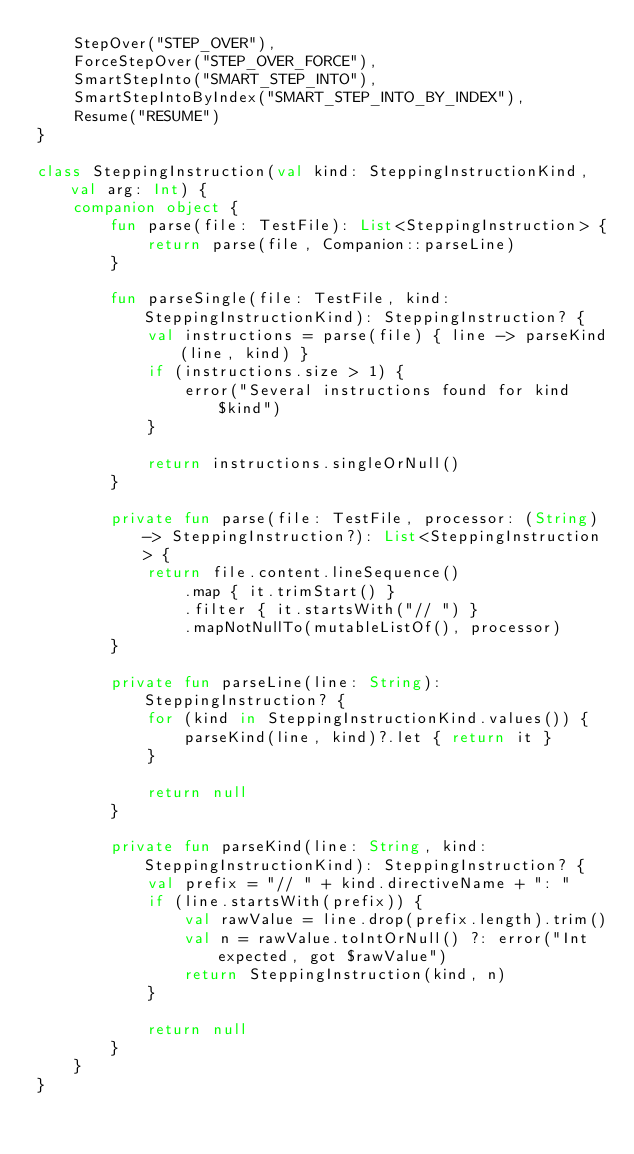<code> <loc_0><loc_0><loc_500><loc_500><_Kotlin_>    StepOver("STEP_OVER"),
    ForceStepOver("STEP_OVER_FORCE"),
    SmartStepInto("SMART_STEP_INTO"),
    SmartStepIntoByIndex("SMART_STEP_INTO_BY_INDEX"),
    Resume("RESUME")
}

class SteppingInstruction(val kind: SteppingInstructionKind, val arg: Int) {
    companion object {
        fun parse(file: TestFile): List<SteppingInstruction> {
            return parse(file, Companion::parseLine)
        }

        fun parseSingle(file: TestFile, kind: SteppingInstructionKind): SteppingInstruction? {
            val instructions = parse(file) { line -> parseKind(line, kind) }
            if (instructions.size > 1) {
                error("Several instructions found for kind $kind")
            }

            return instructions.singleOrNull()
        }

        private fun parse(file: TestFile, processor: (String) -> SteppingInstruction?): List<SteppingInstruction> {
            return file.content.lineSequence()
                .map { it.trimStart() }
                .filter { it.startsWith("// ") }
                .mapNotNullTo(mutableListOf(), processor)
        }

        private fun parseLine(line: String): SteppingInstruction? {
            for (kind in SteppingInstructionKind.values()) {
                parseKind(line, kind)?.let { return it }
            }

            return null
        }

        private fun parseKind(line: String, kind: SteppingInstructionKind): SteppingInstruction? {
            val prefix = "// " + kind.directiveName + ": "
            if (line.startsWith(prefix)) {
                val rawValue = line.drop(prefix.length).trim()
                val n = rawValue.toIntOrNull() ?: error("Int expected, got $rawValue")
                return SteppingInstruction(kind, n)
            }

            return null
        }
    }
}</code> 